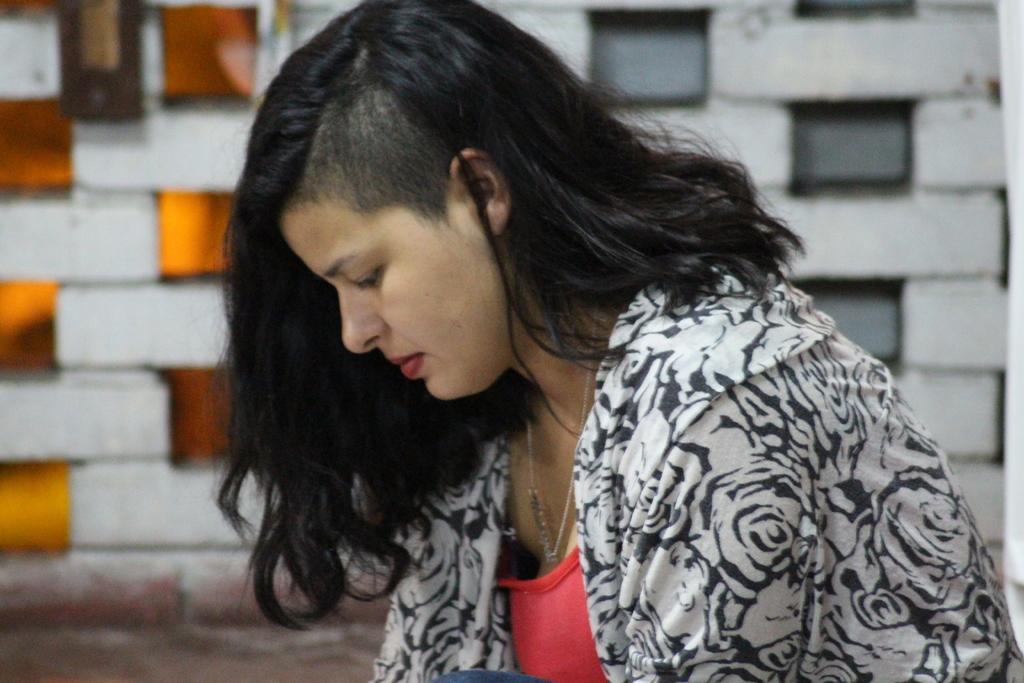Describe this image in one or two sentences. This image consists of a woman wearing white and black jacket. At the bottom, there is a ground. In the background, there is a wall made up of bricks. 